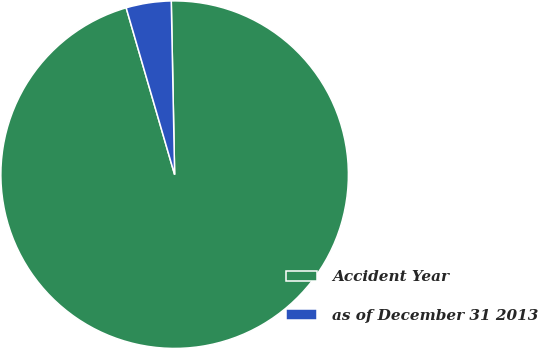Convert chart. <chart><loc_0><loc_0><loc_500><loc_500><pie_chart><fcel>Accident Year<fcel>as of December 31 2013<nl><fcel>95.81%<fcel>4.19%<nl></chart> 